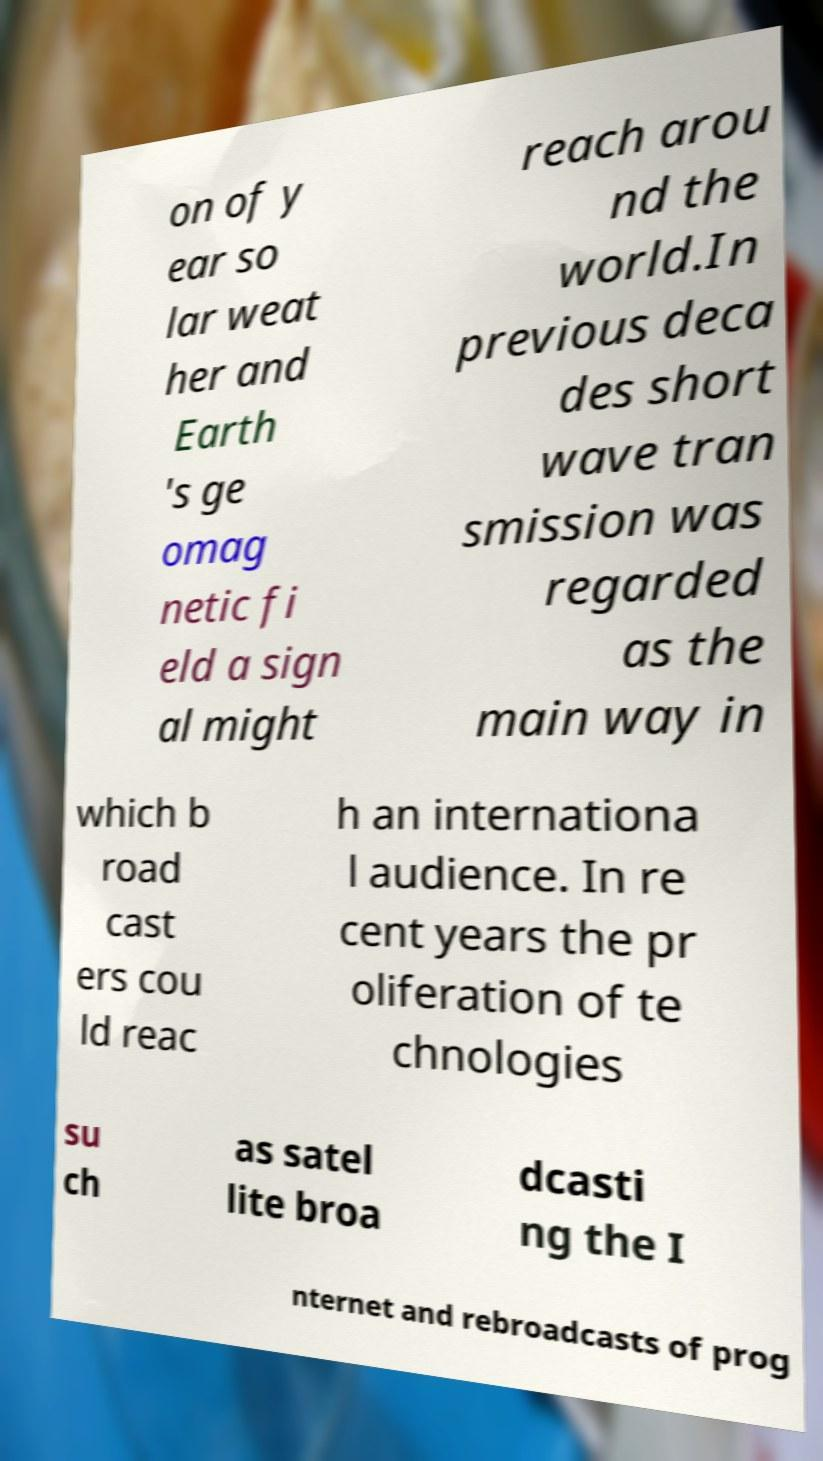Can you accurately transcribe the text from the provided image for me? on of y ear so lar weat her and Earth 's ge omag netic fi eld a sign al might reach arou nd the world.In previous deca des short wave tran smission was regarded as the main way in which b road cast ers cou ld reac h an internationa l audience. In re cent years the pr oliferation of te chnologies su ch as satel lite broa dcasti ng the I nternet and rebroadcasts of prog 